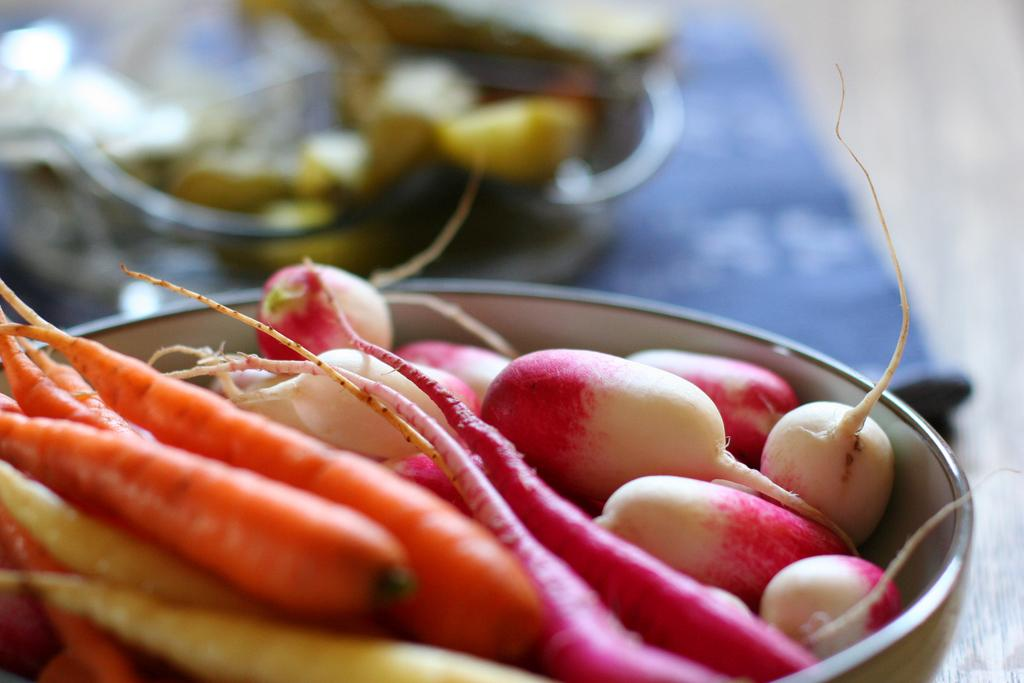What is in the bowl that is visible in the image? There is a bowl in the image, and carrots are present in the bowl. What other types of vegetables can be seen in the bowl? There are other vegetables in the bowl besides carrots. Can you describe the background of the image? The background of the image is blurred. What type of nerve can be seen in the image? There is no nerve present in the image; it features a bowl with vegetables. How does the cattle alarm sound in the image? There is no cattle alarm present in the image. 